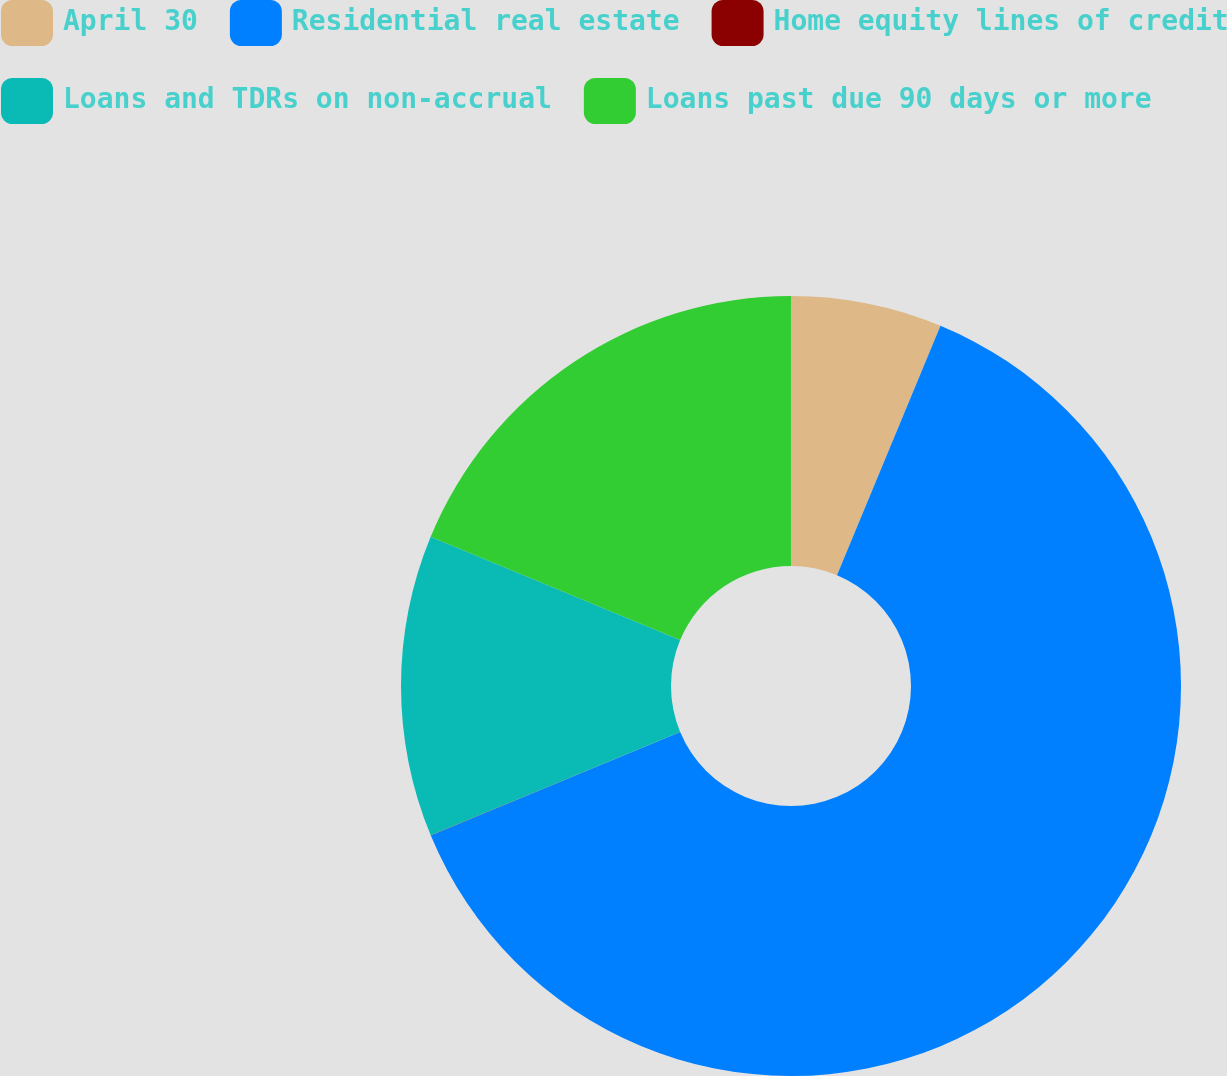Convert chart to OTSL. <chart><loc_0><loc_0><loc_500><loc_500><pie_chart><fcel>April 30<fcel>Residential real estate<fcel>Home equity lines of credit<fcel>Loans and TDRs on non-accrual<fcel>Loans past due 90 days or more<nl><fcel>6.26%<fcel>62.47%<fcel>0.01%<fcel>12.5%<fcel>18.75%<nl></chart> 